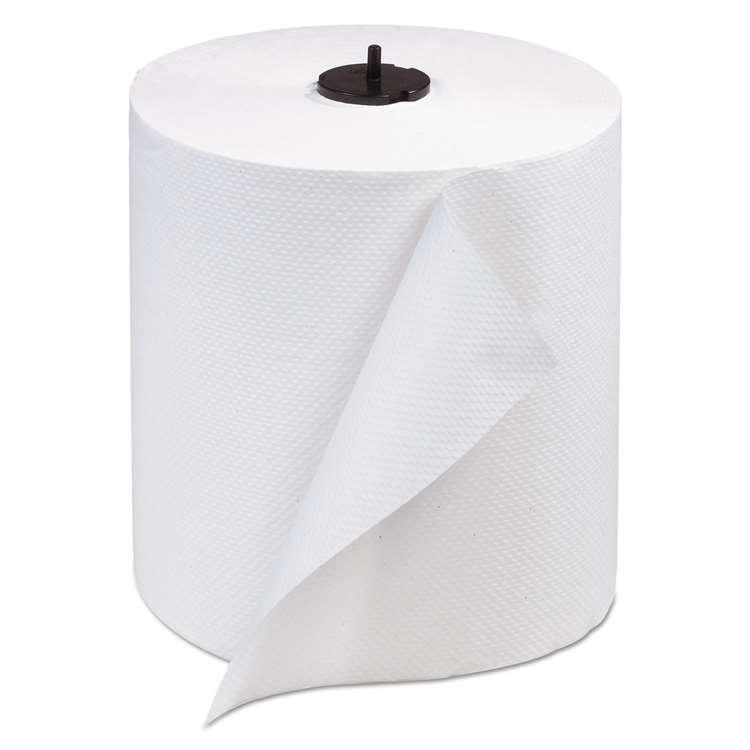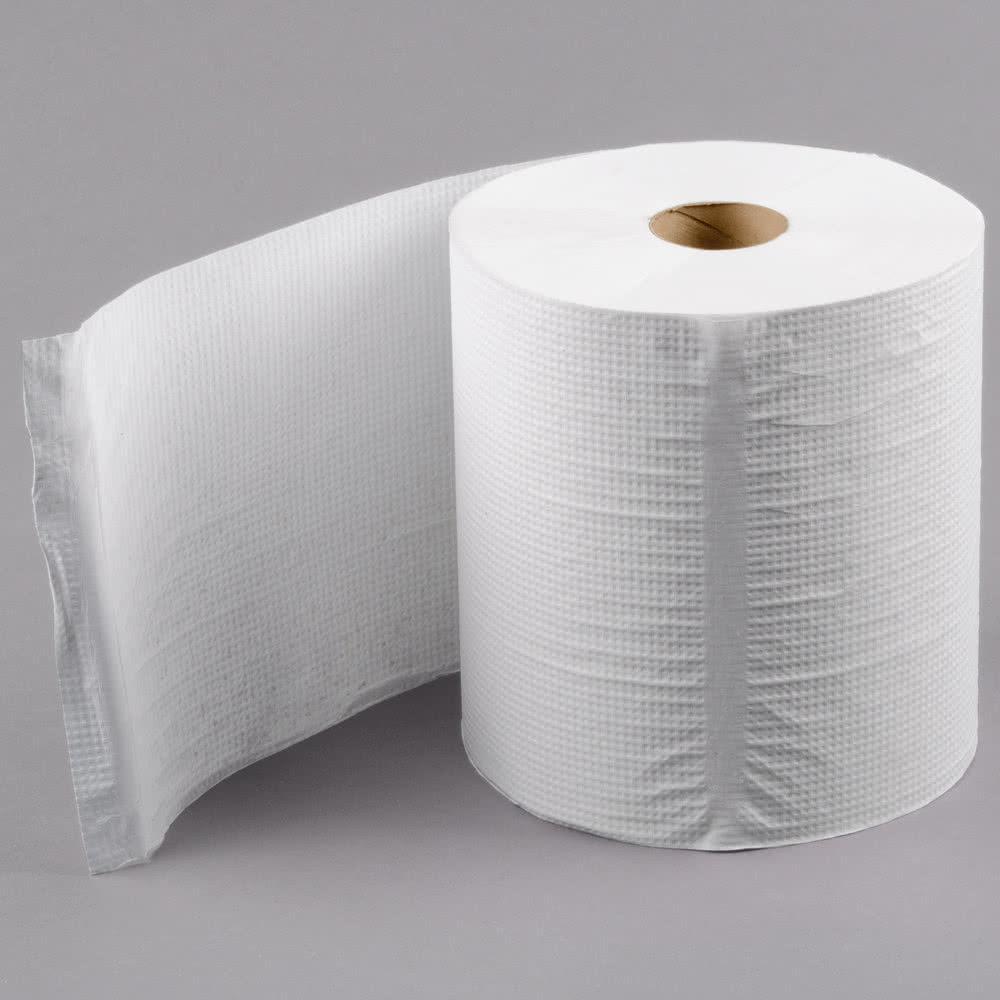The first image is the image on the left, the second image is the image on the right. Given the left and right images, does the statement "Each image features a single white upright roll of paper towels with no sheet of towel extending out past the roll." hold true? Answer yes or no. No. The first image is the image on the left, the second image is the image on the right. Evaluate the accuracy of this statement regarding the images: "In at least one image there is a single role of toilet paper with and open unruptured hole in the middle with the paper unrolling at least one sheet.". Is it true? Answer yes or no. Yes. 